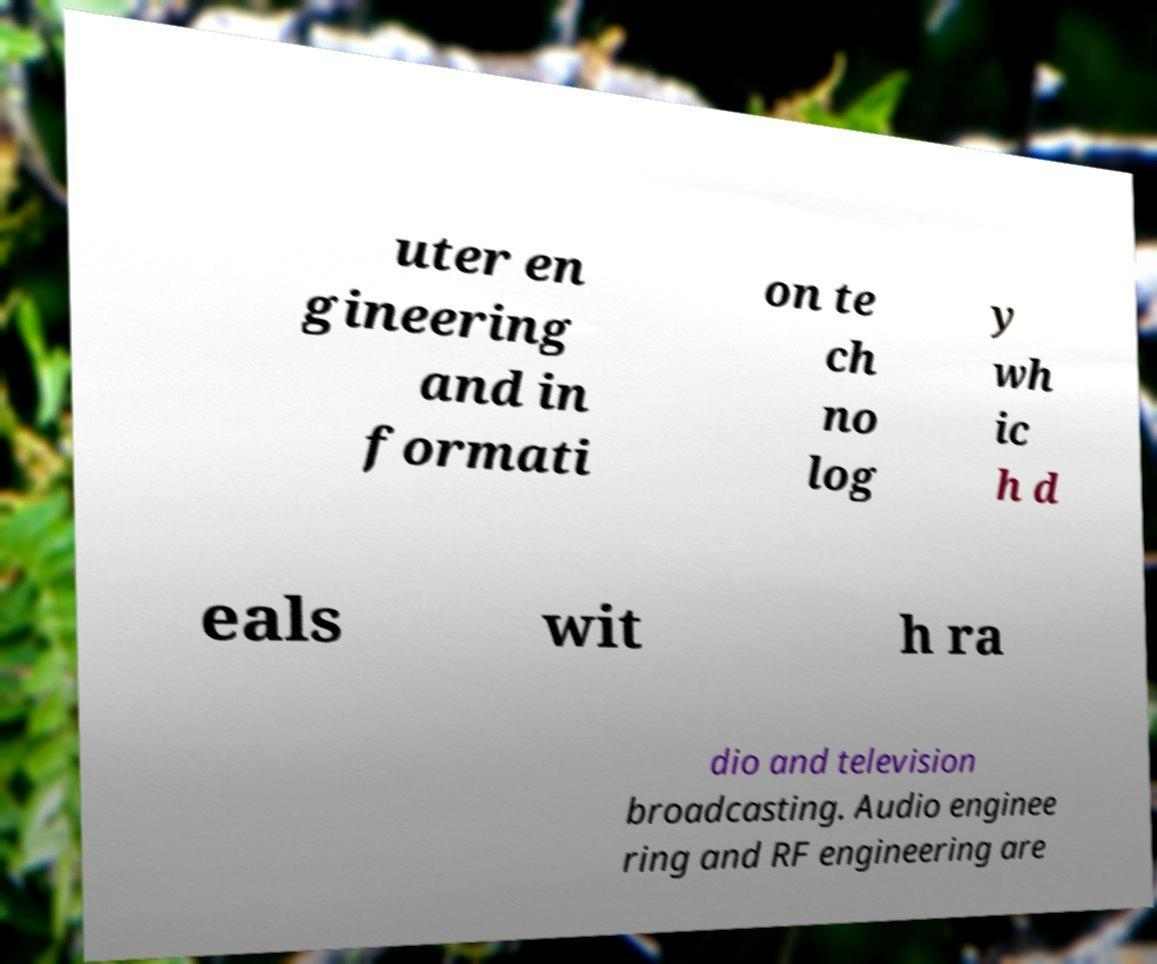What messages or text are displayed in this image? I need them in a readable, typed format. uter en gineering and in formati on te ch no log y wh ic h d eals wit h ra dio and television broadcasting. Audio enginee ring and RF engineering are 